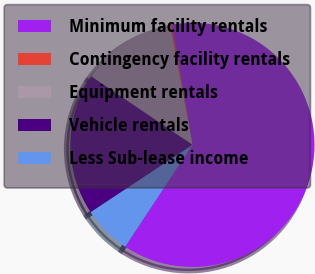Convert chart. <chart><loc_0><loc_0><loc_500><loc_500><pie_chart><fcel>Minimum facility rentals<fcel>Contingency facility rentals<fcel>Equipment rentals<fcel>Vehicle rentals<fcel>Less Sub-lease income<nl><fcel>61.97%<fcel>0.25%<fcel>12.59%<fcel>18.77%<fcel>6.42%<nl></chart> 